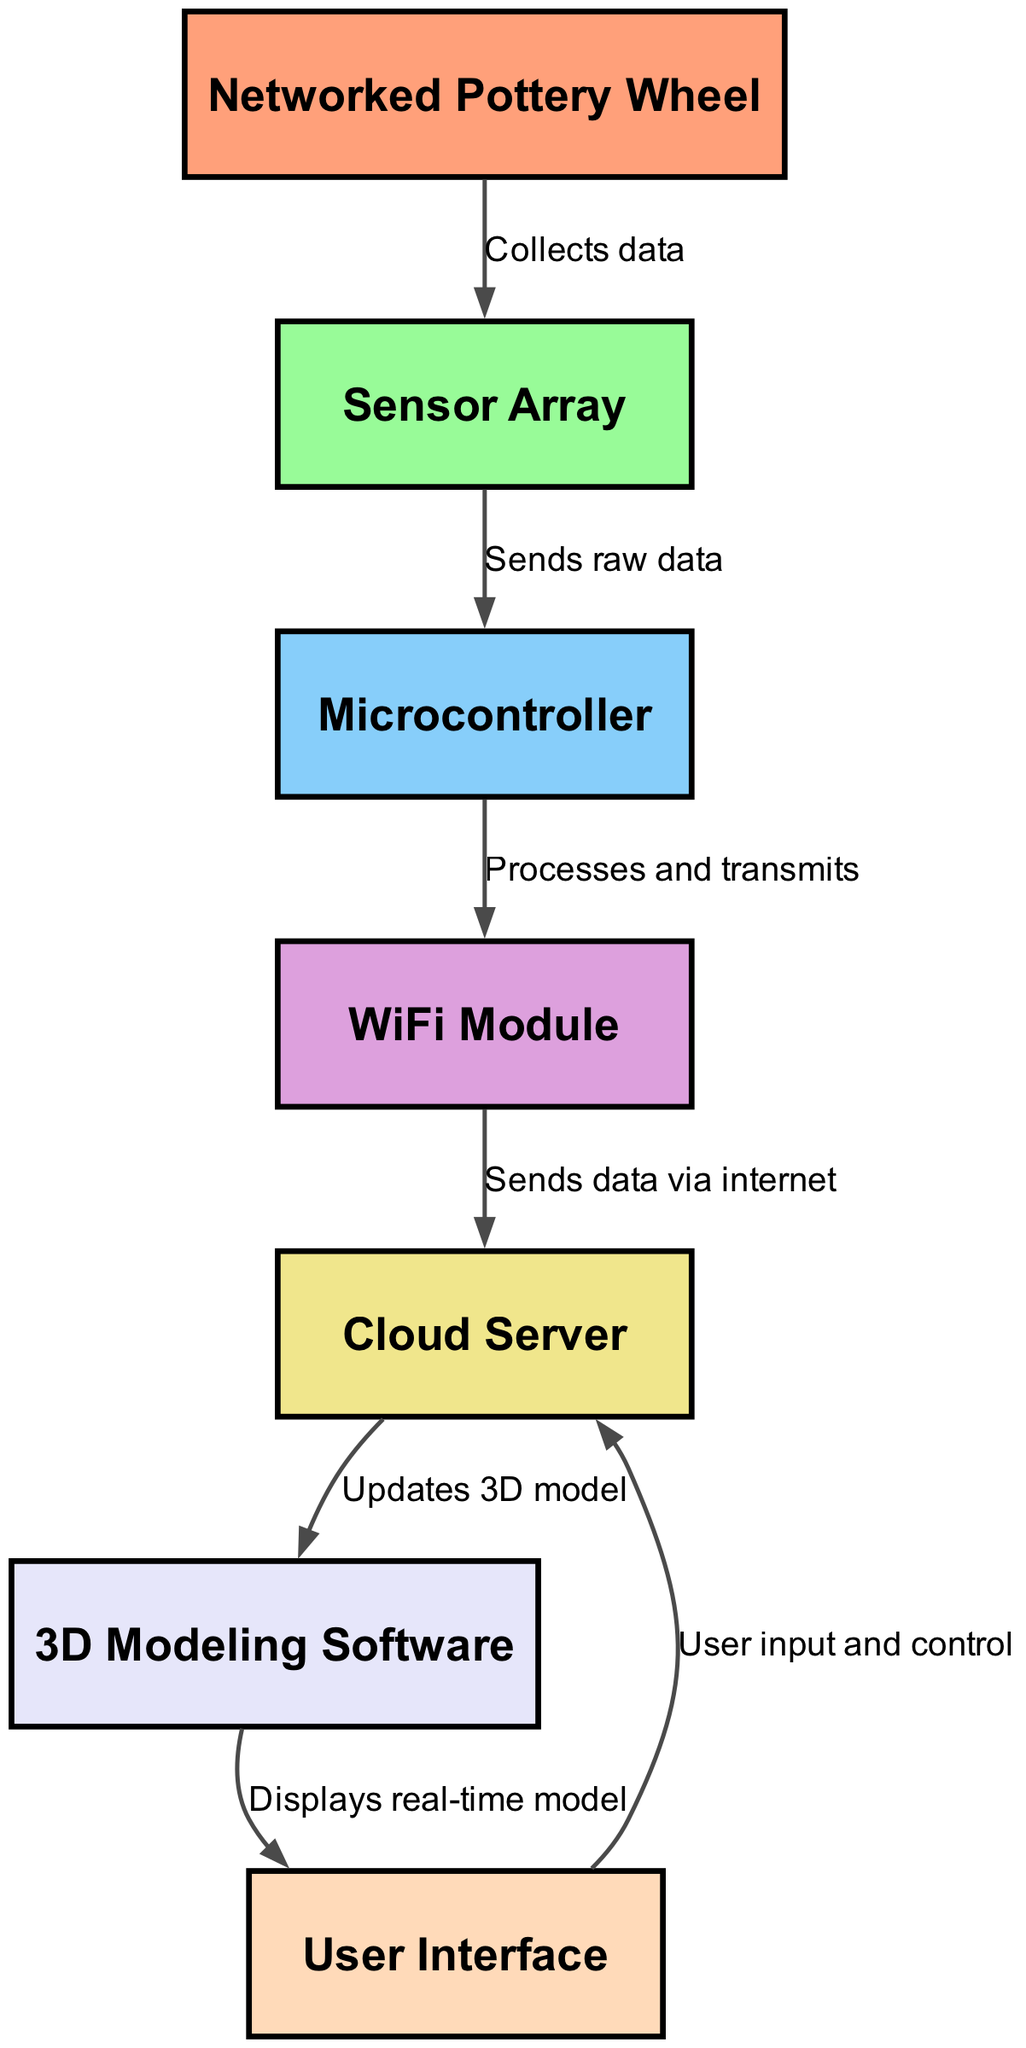What is the total number of nodes in the diagram? The diagram contains seven distinct nodes: Networked Pottery Wheel, Sensor Array, Microcontroller, WiFi Module, Cloud Server, 3D Modeling Software, and User Interface. Counting these gives a total of seven nodes.
Answer: 7 Which node collects data? The edge directed from the "Networked Pottery Wheel" to the "Sensor Array" indicates that the "Sensor Array" is responsible for collecting data from the pottery wheel.
Answer: Sensor Array What type of connection exists between the Microcontroller and the WiFi Module? The edge from the "Microcontroller" to the "WiFi Module" is labeled "Processes and transmits," indicating that the Microcontroller processes the data and transmits it to the WiFi module for further communication.
Answer: Processes and transmits What is the function of the Cloud Server in relation to the 3D Modeling Software? The "Cloud Server" sends data to the "3D Modeling Software" to update the digital model, indicating that it plays a crucial role in syncing real-world actions with digital representations.
Answer: Updates 3D model How does the User Interface interact with the Cloud Server? The arrow shows that the "User Interface" sends user input and control signals back to the "Cloud Server," indicating a feedback loop where the user can influence the cloud-based operations.
Answer: User input and control What is the data flow direction between the Sensor Array and the Microcontroller? The edge from "Sensor Array" to "Microcontroller" is directed, indicating that data flows from the Sensor Array to the Microcontroller for processing.
Answer: Sends raw data Which component is responsible for internet communication? The "WiFi Module" is indicated to be the component that communicates with the internet via the Cloud Server, as it transmits processed data from the Microcontroller to the Cloud Server.
Answer: WiFi Module What visual relationship exists between the 3D Modeling Software and the User Interface? The "3D Modeling Software" displays a real-time model on the "User Interface," suggesting a direct visual relationship where users can interact with the graphical output in real-time.
Answer: Displays real-time model 